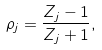<formula> <loc_0><loc_0><loc_500><loc_500>\rho _ { j } = \frac { Z _ { j } - 1 } { Z _ { j } + 1 } ,</formula> 